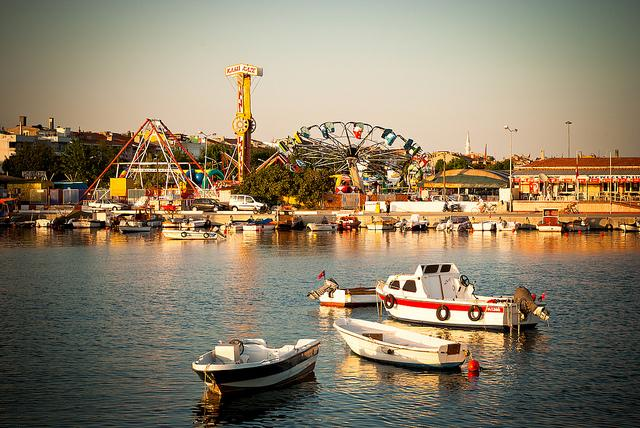Where can you see a similar scene to what is happening behind the boats? Please explain your reasoning. six flags. An amusement park is back there. 